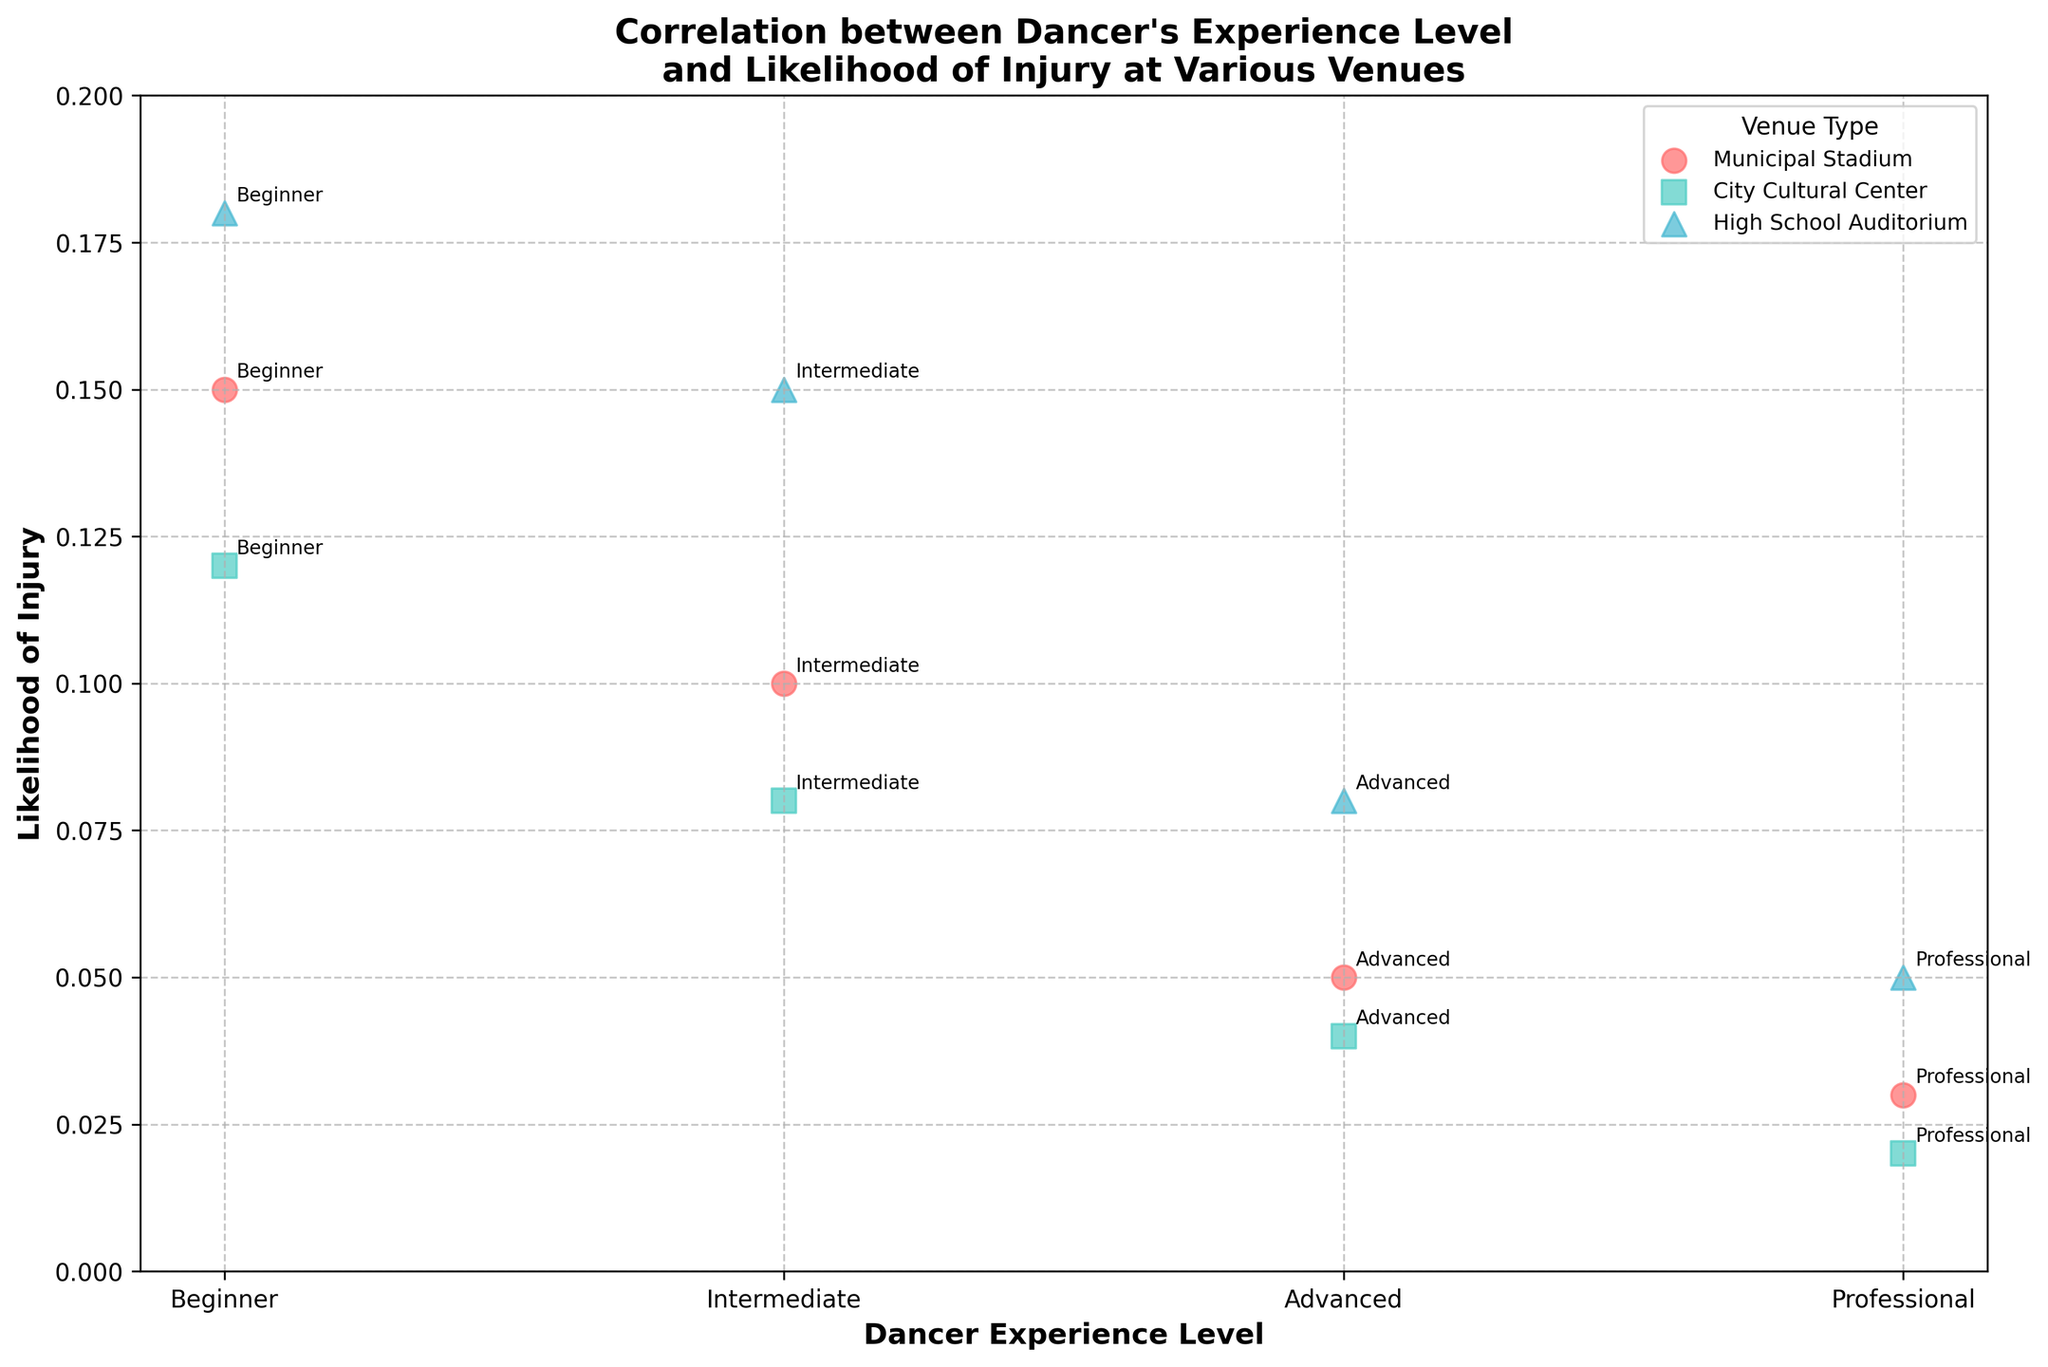What is the title of the figure? The title of the scatter plot is found at the top of the figure and provides a summary of what the plot represents.
Answer: Correlation between Dancer's Experience Level and Likelihood of Injury at Various Venues What is the likelihood of injury for professional dancers at a municipal stadium? Locate the data point for professional dancers corresponding to the municipal stadium (represented by a specific color and marker). The scatter plot annotation next to that point shows the likelihood of injury.
Answer: 0.03 Which dancer experience level has the highest likelihood of injury at a high school auditorium? Identify the data points labeled as "High School Auditorium" and compare the likelihoods of injury for different experience levels.
Answer: Beginner What is the range of likelihood of injury for dancers at the city cultural center? Review all the data points for the city cultural center and identify the maximum and minimum likelihood values.
Answer: 0.02 to 0.12 Compare the likelihood of injury for intermediate and advanced dancers at the municipal stadium. Which group has a lower likelihood of injury and by how much? Identify the data points for intermediate and advanced dancers at the municipal stadium, then subtract the smaller likelihood value from the larger one. Intermediate: 0.10, Advanced: 0.05. The difference is 0.10 - 0.05.
Answer: Advanced by 0.05 Which venue has the most consistent likelihood of injury across all experience levels? Determine the venue with the smallest range of likelihood values when comparing data points for different experience levels. This involves comparing the variability for each venue.
Answer: City Cultural Center Is the likelihood of injury generally higher for beginners as compared to professionals across all venues? Compare the data points for beginners and professionals across each venue and identify a general trend. Beginners mostly have higher values (0.15, 0.12, 0.18) compared to professionals (0.03, 0.02, 0.05).
Answer: Yes Do advanced dancers have a consistent decrease in the likelihood of injury compared to intermediate dancers across all venues? Examine each venue's data points for advanced and intermediate dancers and compare the likelihoods of injury. Municipal Stadium: Advanced (0.05) < Intermediate (0.10), City Cultural Center: Advanced (0.04) < Intermediate (0.08), High School Auditorium: Advanced (0.08) < Intermediate (0.15). This shows a consistent decrease.
Answer: Yes Which dancer experience level shows the most variation in the likelihood of injury across different venues? Review the likelihood of injury values for each experience level across all venues and determine which has the largest range (difference between max and min values). Beginner: 0.18 - 0.12 = 0.06, Intermediate: 0.15 - 0.08 = 0.07, Advanced: 0.08 - 0.04 = 0.04, Professional: 0.05 - 0.02 = 0.03.
Answer: Intermediate What is the trend in likelihood of injury as dancer experience level increases at the municipal stadium? Analyze the scatter points at the municipal stadium for different dancer experience levels, noting how the likelihood values change from beginner to professional. Beginner: 0.15, Intermediate: 0.10, Advanced: 0.05, Professional: 0.03. The values decrease as experience increases.
Answer: Decreasing 